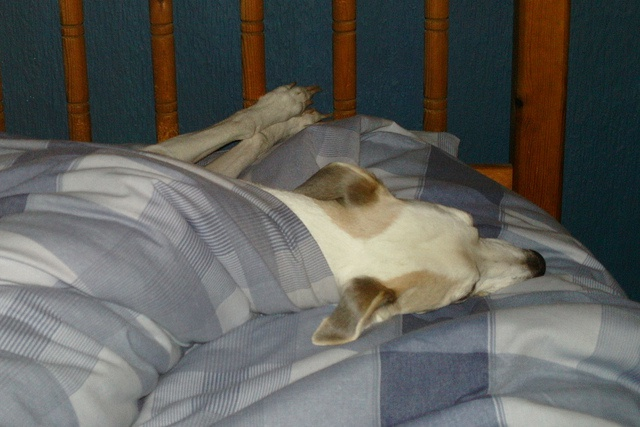Describe the objects in this image and their specific colors. I can see bed in black, gray, and darkgray tones and dog in black, gray, tan, and beige tones in this image. 